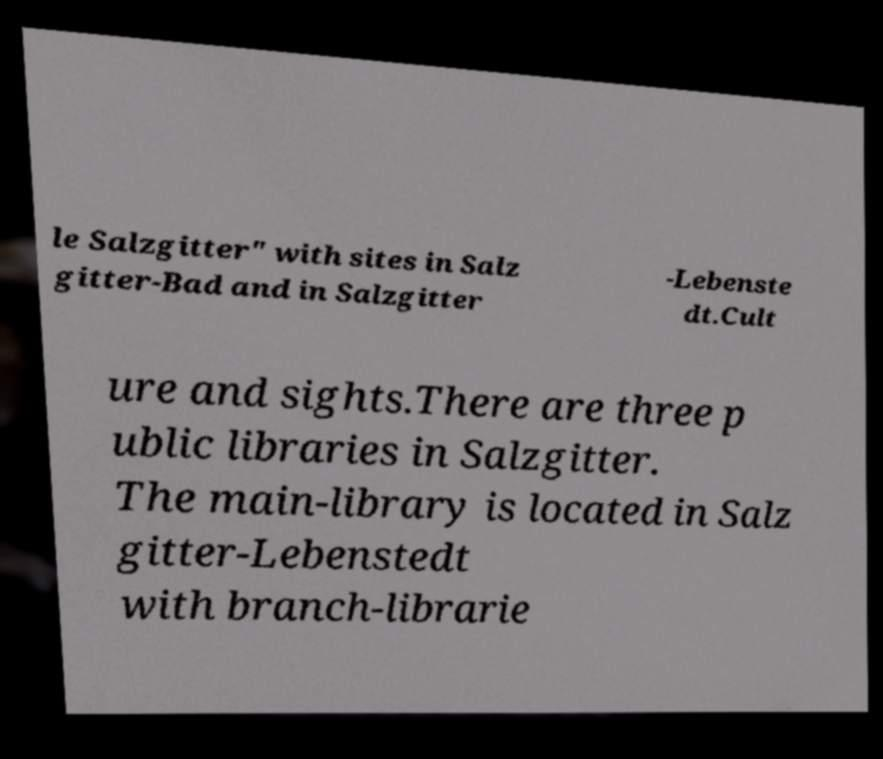What messages or text are displayed in this image? I need them in a readable, typed format. le Salzgitter" with sites in Salz gitter-Bad and in Salzgitter -Lebenste dt.Cult ure and sights.There are three p ublic libraries in Salzgitter. The main-library is located in Salz gitter-Lebenstedt with branch-librarie 